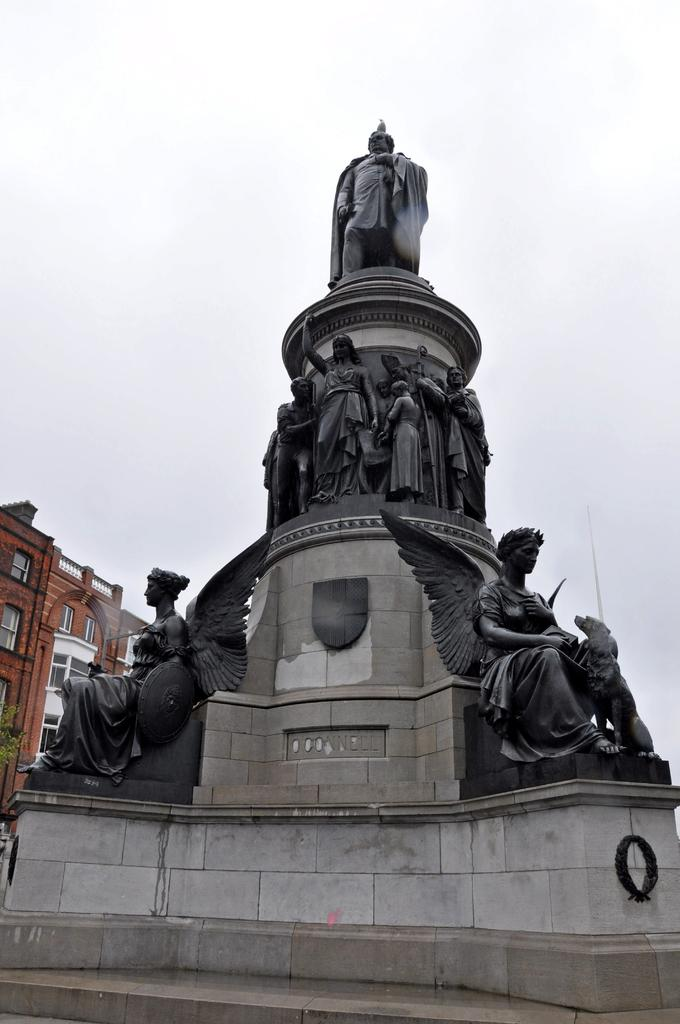What type of art is present in the image? There are sculptures in the image. Can you describe the building in the background of the image? There is a red-colored building in the background of the image. Where is the boy sitting on the chair in the image? There is no boy or chair present in the image; it only features sculptures and a red-colored building in the background. 